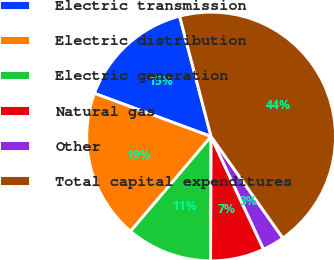Convert chart. <chart><loc_0><loc_0><loc_500><loc_500><pie_chart><fcel>Electric transmission<fcel>Electric distribution<fcel>Electric generation<fcel>Natural gas<fcel>Other<fcel>Total capital expenditures<nl><fcel>15.29%<fcel>19.43%<fcel>11.14%<fcel>7.0%<fcel>2.86%<fcel>44.28%<nl></chart> 